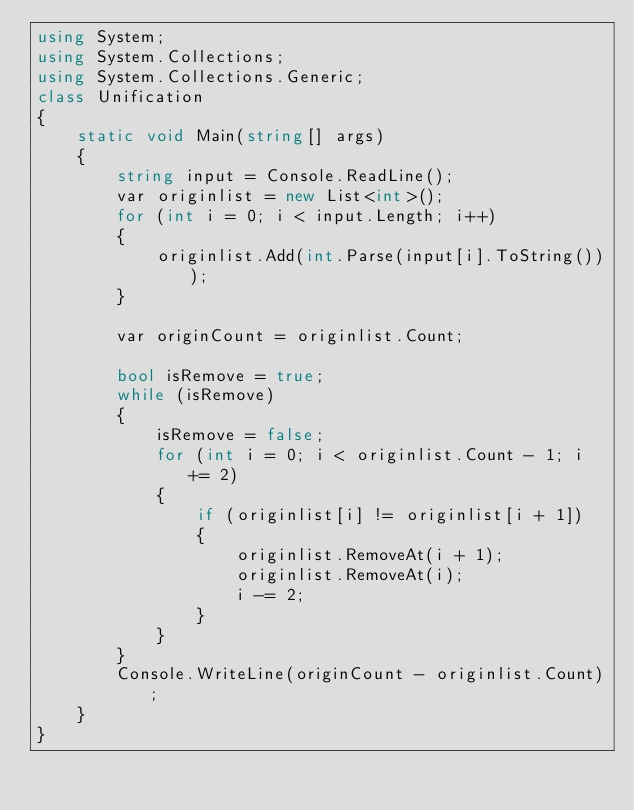<code> <loc_0><loc_0><loc_500><loc_500><_C#_>using System;
using System.Collections;
using System.Collections.Generic;
class Unification
{
    static void Main(string[] args)
    {
        string input = Console.ReadLine();
        var originlist = new List<int>();
        for (int i = 0; i < input.Length; i++)
        {
            originlist.Add(int.Parse(input[i].ToString()));
        }

        var originCount = originlist.Count;

        bool isRemove = true;
        while (isRemove)
        {
            isRemove = false;
            for (int i = 0; i < originlist.Count - 1; i += 2)
            {
                if (originlist[i] != originlist[i + 1])
                {
                    originlist.RemoveAt(i + 1);
                    originlist.RemoveAt(i);
                    i -= 2;
                }
            }
        }
        Console.WriteLine(originCount - originlist.Count);
    }
}</code> 